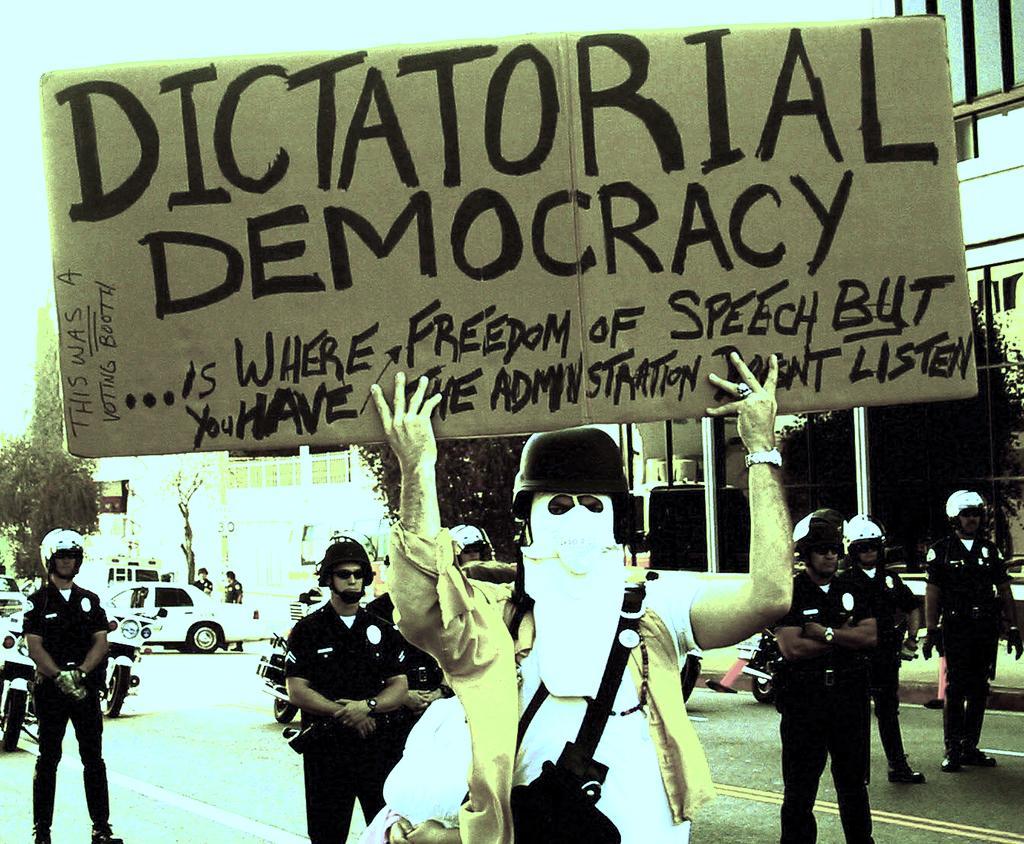Please provide a concise description of this image. In this picture we can see some people are standing, a person in the front is holding a board, there is some text on the board, these people wore helmets, in the background there are buildings and trees, on the left side we can see a car and bikes. 